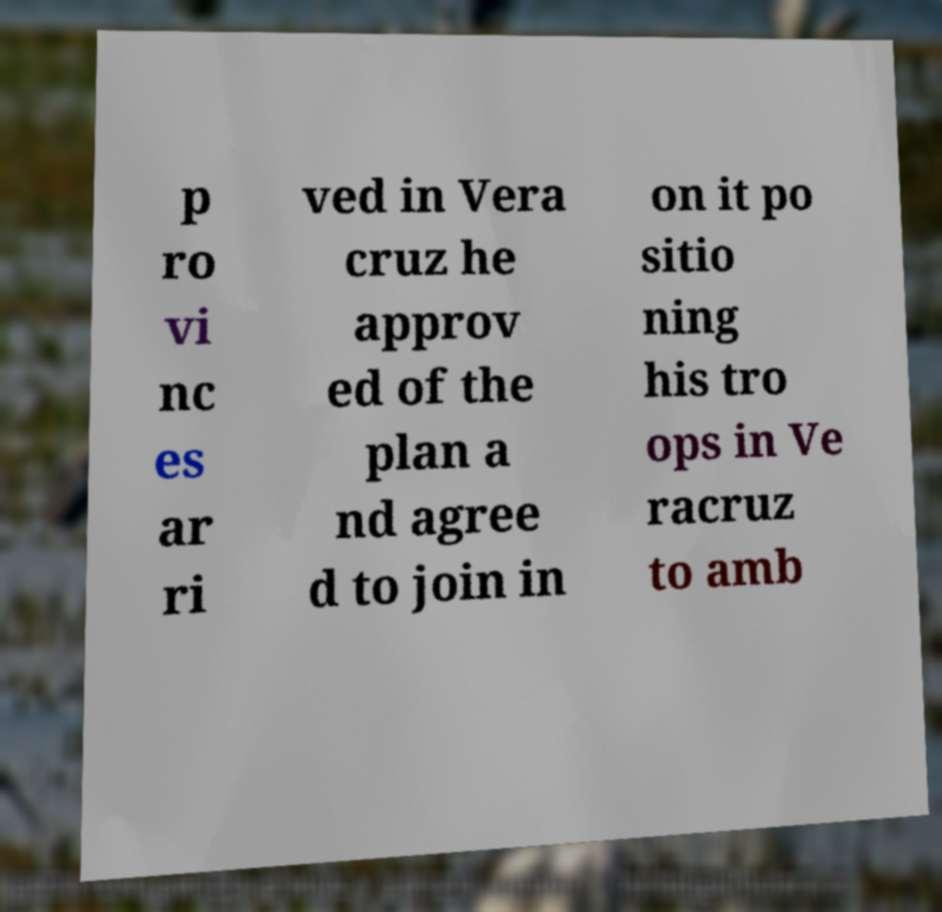I need the written content from this picture converted into text. Can you do that? p ro vi nc es ar ri ved in Vera cruz he approv ed of the plan a nd agree d to join in on it po sitio ning his tro ops in Ve racruz to amb 